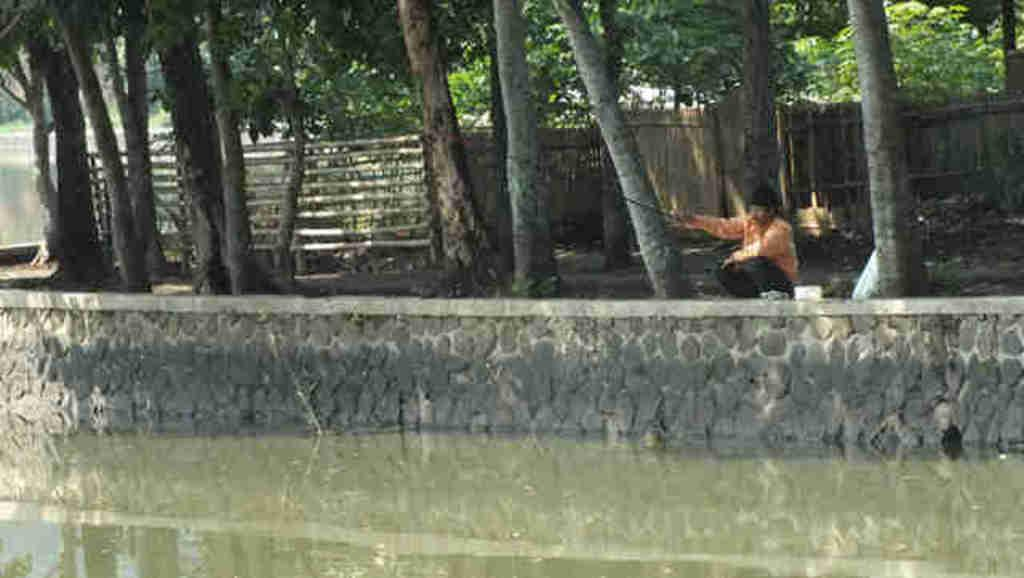What is located in the foreground of the picture? There is a water body and a wall in the foreground of the picture. What can be seen in the center of the picture? There are trees, fencing, and a person fishing in the center of the picture. What is present in the background of the picture? There are trees in the background of the picture. How many pizzas can be seen in the picture? There are no pizzas present in the image. Can you tell me where the person with the ticket is located in the picture? There is no person with a ticket mentioned or visible in the image. 